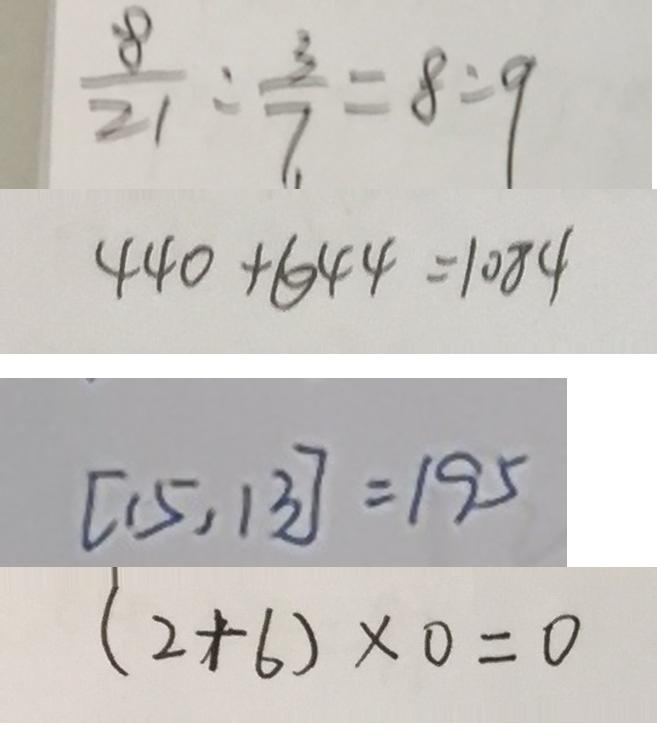Convert formula to latex. <formula><loc_0><loc_0><loc_500><loc_500>\frac { 8 } { 2 1 } : \frac { 3 } { 7 } = 8 : 9 
 4 4 0 + 6 4 4 = 1 0 8 4 
 [ 1 5 , 1 3 ] = 1 9 5 
 ( 2 + 6 ) \times 0 = 0</formula> 